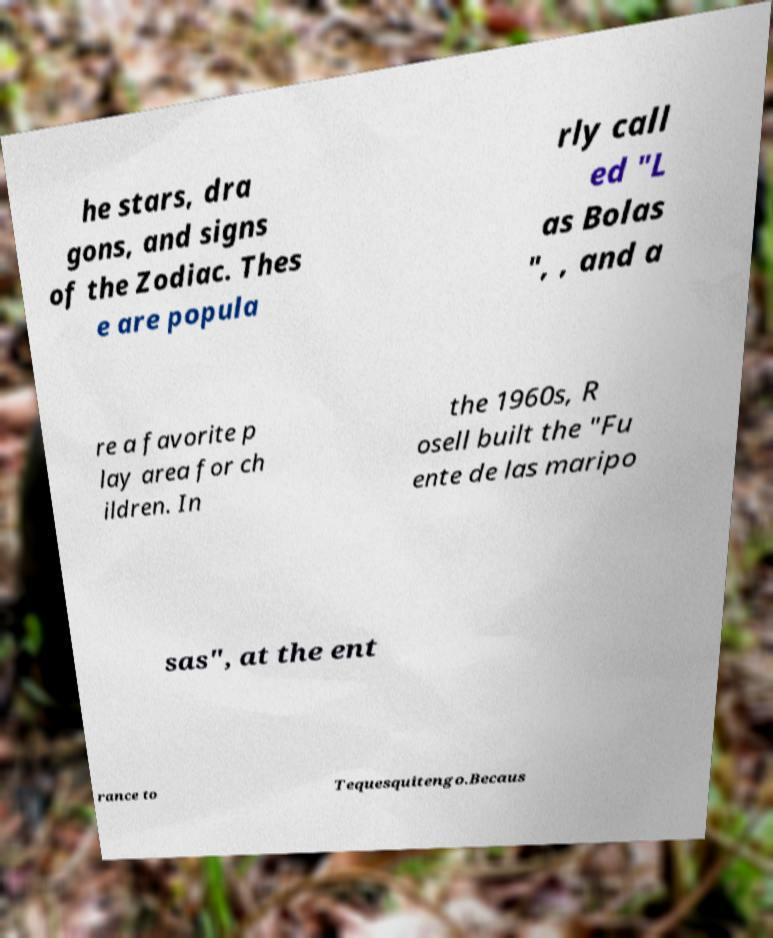Can you accurately transcribe the text from the provided image for me? he stars, dra gons, and signs of the Zodiac. Thes e are popula rly call ed "L as Bolas ", , and a re a favorite p lay area for ch ildren. In the 1960s, R osell built the "Fu ente de las maripo sas", at the ent rance to Tequesquitengo.Becaus 